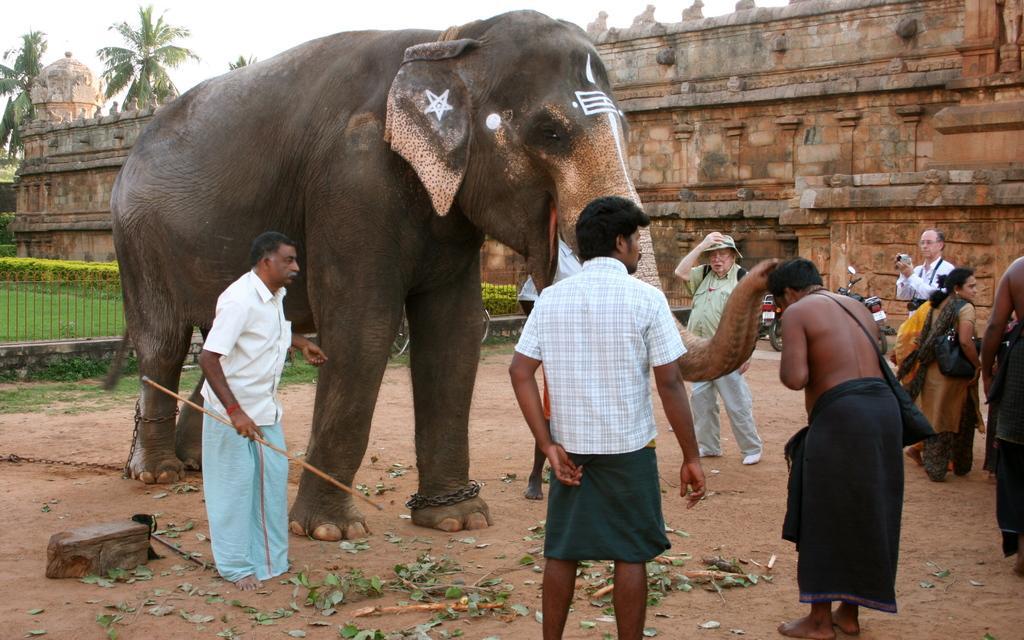In one or two sentences, can you explain what this image depicts? This picture shows a building few trees and a elephant and few people standing around the elephant and a person taking photograph 